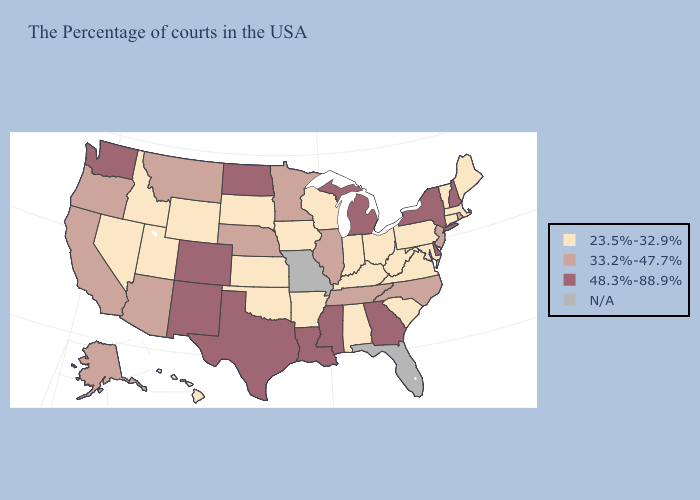What is the value of Massachusetts?
Give a very brief answer. 23.5%-32.9%. Does the map have missing data?
Quick response, please. Yes. What is the value of Kentucky?
Concise answer only. 23.5%-32.9%. Does Rhode Island have the highest value in the USA?
Short answer required. No. What is the value of California?
Write a very short answer. 33.2%-47.7%. Does Michigan have the highest value in the MidWest?
Be succinct. Yes. Among the states that border Nebraska , does Iowa have the lowest value?
Write a very short answer. Yes. What is the highest value in the MidWest ?
Keep it brief. 48.3%-88.9%. Which states have the lowest value in the Northeast?
Short answer required. Maine, Massachusetts, Vermont, Connecticut, Pennsylvania. Name the states that have a value in the range 33.2%-47.7%?
Keep it brief. Rhode Island, New Jersey, North Carolina, Tennessee, Illinois, Minnesota, Nebraska, Montana, Arizona, California, Oregon, Alaska. Name the states that have a value in the range 23.5%-32.9%?
Be succinct. Maine, Massachusetts, Vermont, Connecticut, Maryland, Pennsylvania, Virginia, South Carolina, West Virginia, Ohio, Kentucky, Indiana, Alabama, Wisconsin, Arkansas, Iowa, Kansas, Oklahoma, South Dakota, Wyoming, Utah, Idaho, Nevada, Hawaii. What is the highest value in the USA?
Be succinct. 48.3%-88.9%. Does New York have the highest value in the USA?
Write a very short answer. Yes. 